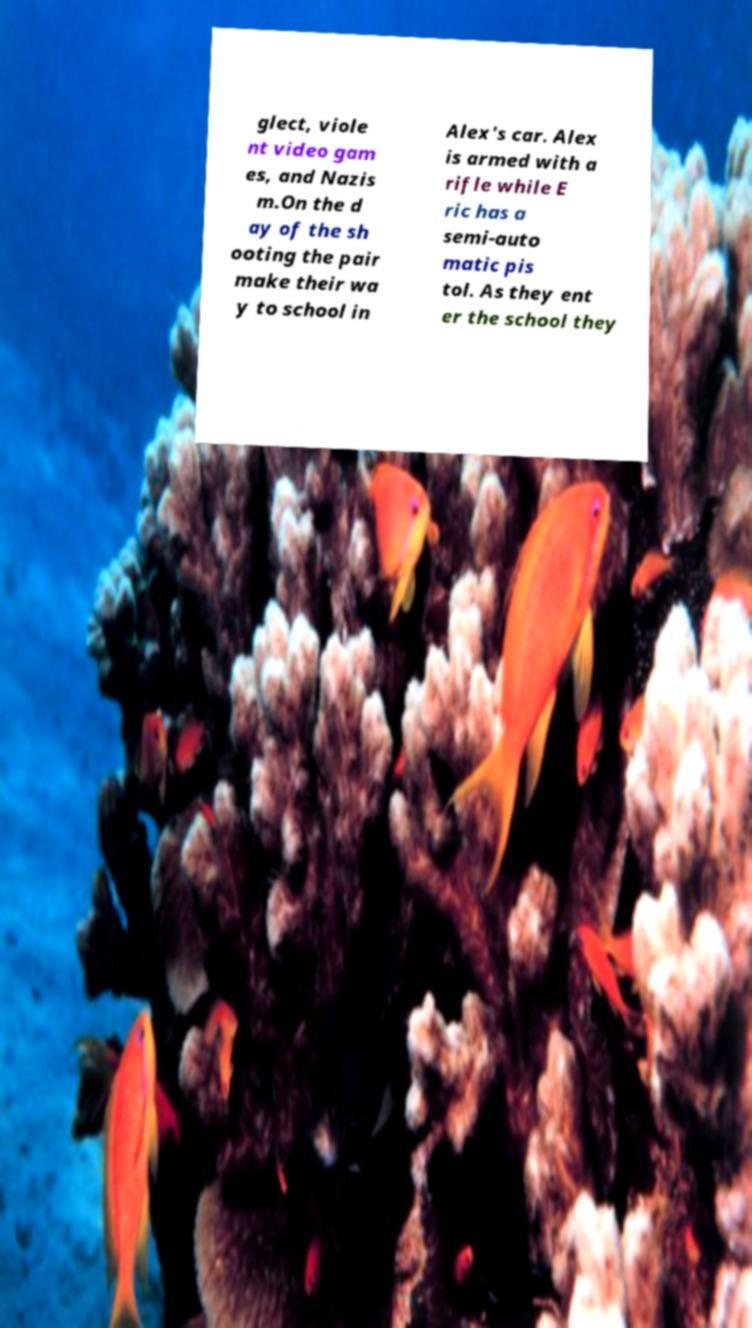Can you read and provide the text displayed in the image?This photo seems to have some interesting text. Can you extract and type it out for me? glect, viole nt video gam es, and Nazis m.On the d ay of the sh ooting the pair make their wa y to school in Alex's car. Alex is armed with a rifle while E ric has a semi-auto matic pis tol. As they ent er the school they 